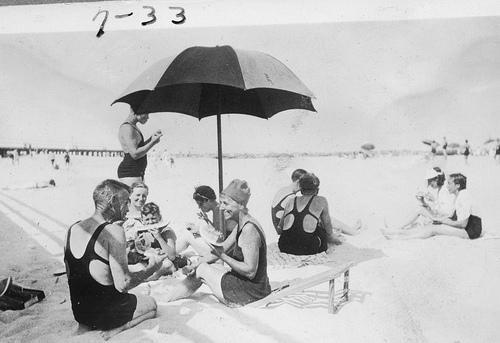How many umbrellas are there?
Give a very brief answer. 1. 